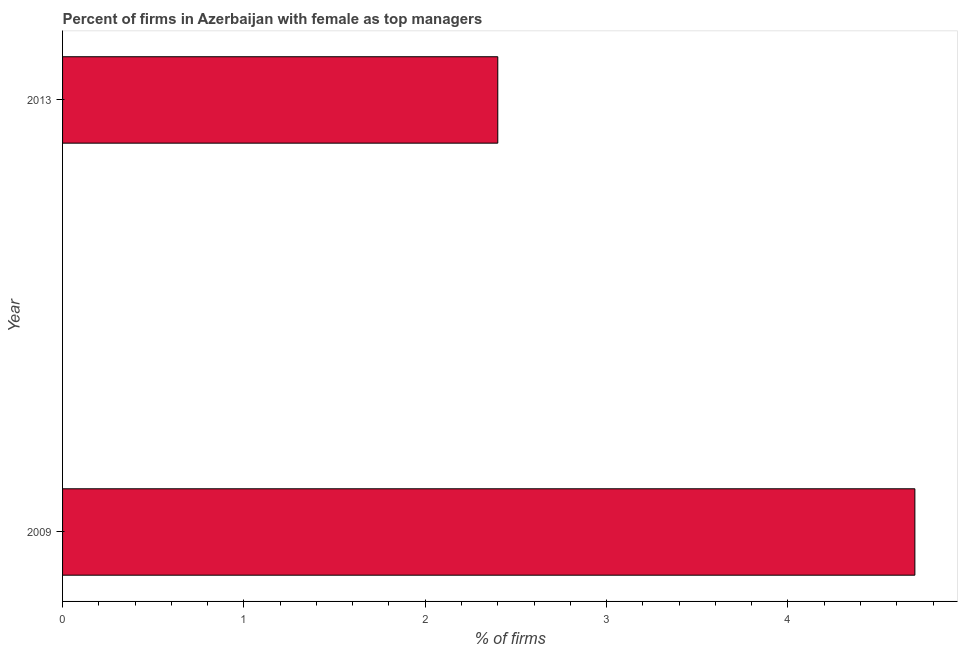Does the graph contain grids?
Offer a very short reply. No. What is the title of the graph?
Your response must be concise. Percent of firms in Azerbaijan with female as top managers. What is the label or title of the X-axis?
Offer a terse response. % of firms. What is the label or title of the Y-axis?
Ensure brevity in your answer.  Year. What is the percentage of firms with female as top manager in 2009?
Your answer should be compact. 4.7. Across all years, what is the minimum percentage of firms with female as top manager?
Make the answer very short. 2.4. In which year was the percentage of firms with female as top manager maximum?
Your answer should be compact. 2009. What is the sum of the percentage of firms with female as top manager?
Make the answer very short. 7.1. What is the average percentage of firms with female as top manager per year?
Keep it short and to the point. 3.55. What is the median percentage of firms with female as top manager?
Provide a succinct answer. 3.55. In how many years, is the percentage of firms with female as top manager greater than 2.8 %?
Offer a very short reply. 1. What is the ratio of the percentage of firms with female as top manager in 2009 to that in 2013?
Offer a very short reply. 1.96. Is the percentage of firms with female as top manager in 2009 less than that in 2013?
Your answer should be very brief. No. How many bars are there?
Make the answer very short. 2. Are all the bars in the graph horizontal?
Your answer should be very brief. Yes. How many years are there in the graph?
Keep it short and to the point. 2. What is the difference between two consecutive major ticks on the X-axis?
Offer a terse response. 1. What is the difference between the % of firms in 2009 and 2013?
Provide a succinct answer. 2.3. What is the ratio of the % of firms in 2009 to that in 2013?
Your answer should be very brief. 1.96. 